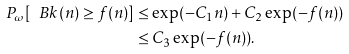Convert formula to latex. <formula><loc_0><loc_0><loc_500><loc_500>P _ { \omega } [ \ B k ( n ) \geq f ( n ) ] & \leq \exp ( - C _ { 1 } n ) + C _ { 2 } \exp ( - f ( n ) ) \\ & \leq C _ { 3 } \exp ( - f ( n ) ) .</formula> 